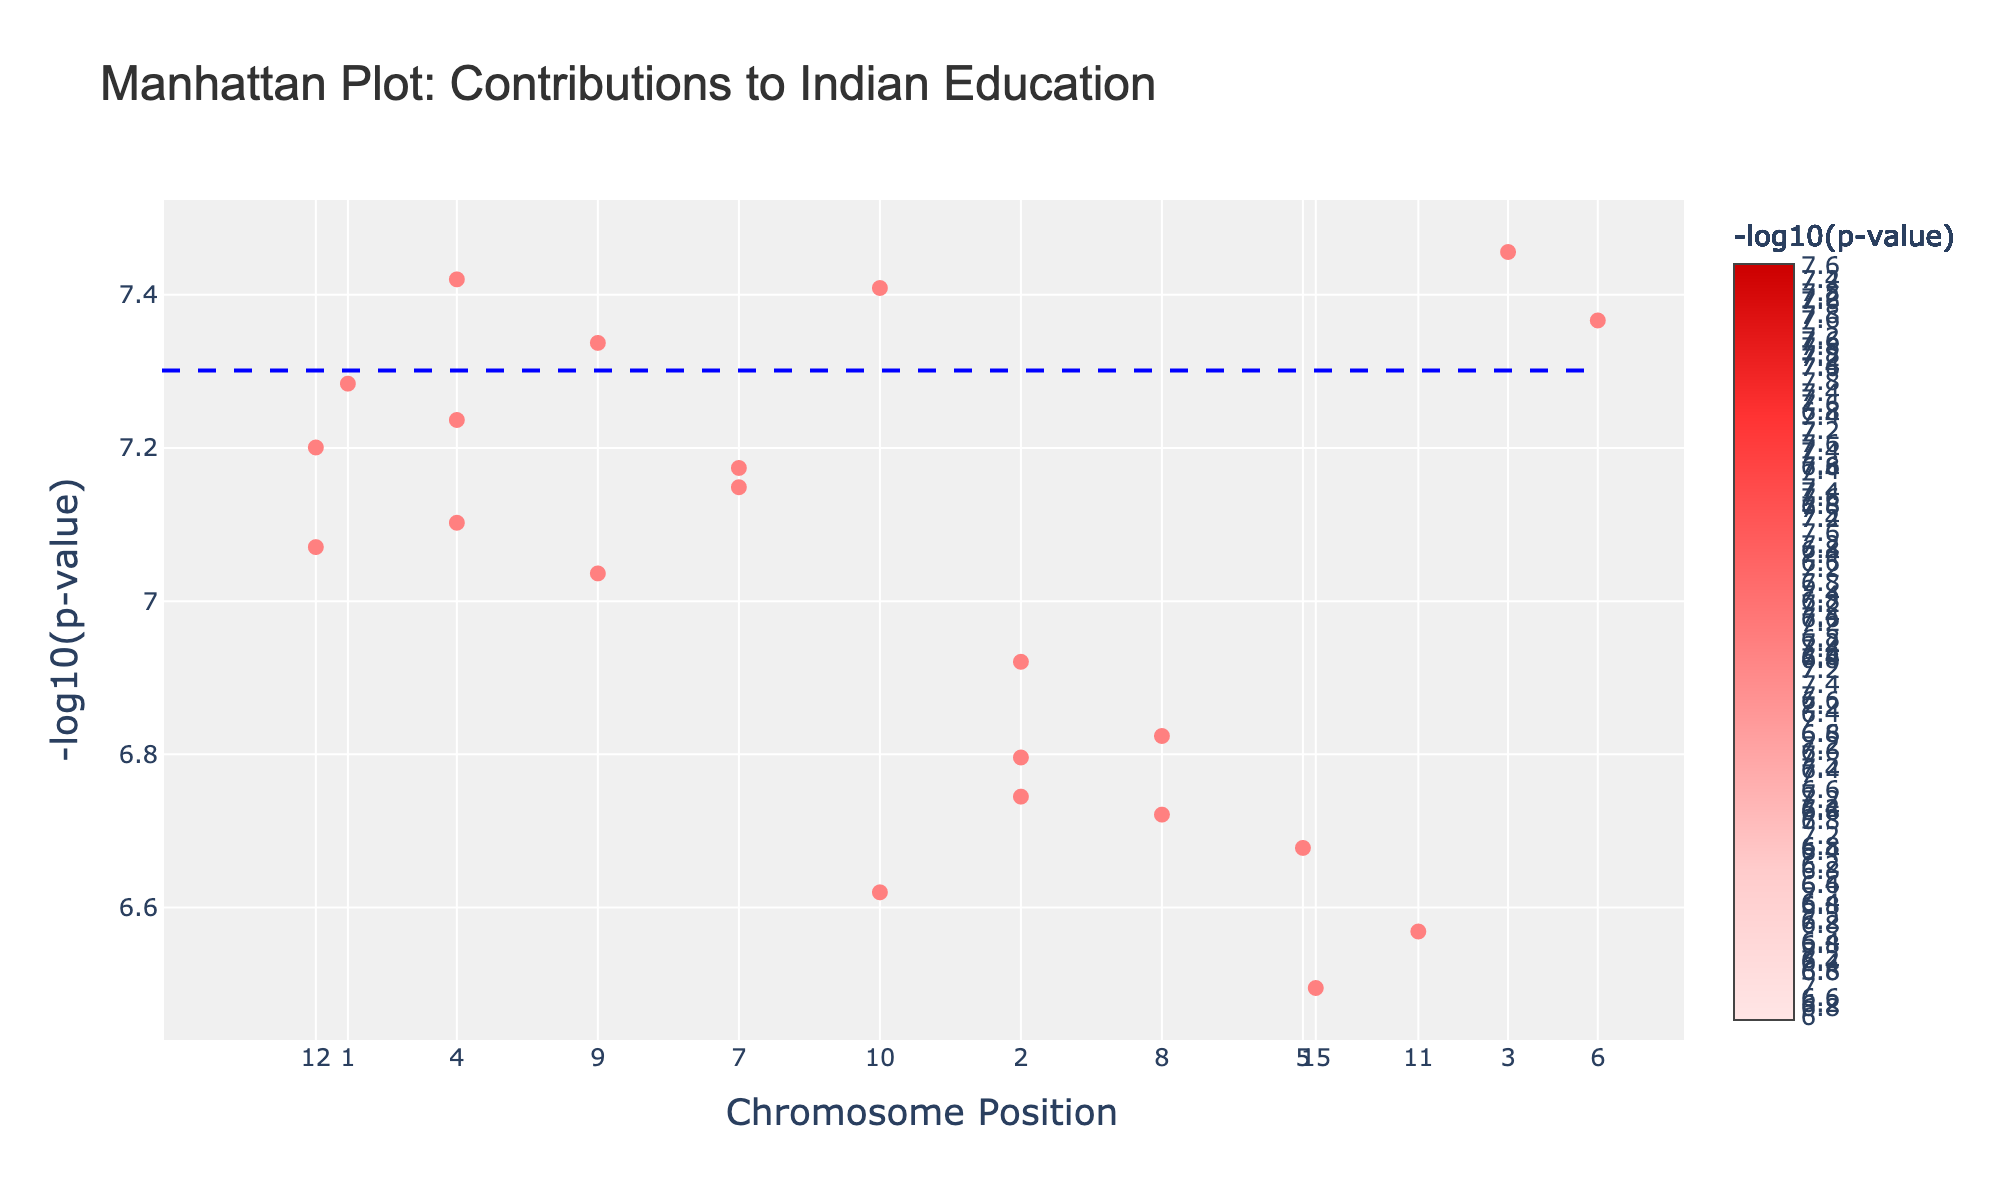What is the title of the plot? The title of the plot is written at the top and provides a summary of the content being displayed.
Answer: Manhattan Plot: Contributions to Indian Education What is the significance threshold line value? The significance threshold line value is found by observing the horizontal dashed line on the plot, which corresponds to -log10(5e-8).
Answer: -log10(5e-8) Which figure has the lowest p-value? The lowest p-value corresponds to the highest -log10(p-value) since the y-axis represents -log10(p-value). Identify the highest point on the y-axis.
Answer: Rabindranath Tagore How many significant loci are there with -log10(p-value) greater than 7? Count all the data points that have their -log10(p-value) values above 7 by observing the y-axis and the data points that surpass this threshold.
Answer: 2 Which chromosome has the highest number of significant loci? Compare the number of data points for each chromosome by analyzing each segment of the plot visually and counting the points in each.
Answer: Chromosome 2 What figure is represented by the significant locus on Chromosome 6? Identify the data point on Chromosome 6 with the highest -log10(p-value), check the tooltip/data label for this point to find the figure it represents.
Answer: Annie Besant Which figures have significant loci located between positions 20,000,000 and 80,000,000 on the x-axis? Look at the x-axis range from 20,000,000 to 80,000,000 positions and identify the figures corresponding to the data points within this range.
Answer: Sarvepalli Radhakrishnan, Savitribai Phule, Jayachamarajendra Wadiyar Which figure on Chromosome 15 has the highest -log10(p-value)? Identify and compare the -log10(p-values) of data points on Chromosome 15 and find the maximum value, then locate the corresponding figure.
Answer: Amartya Sen 